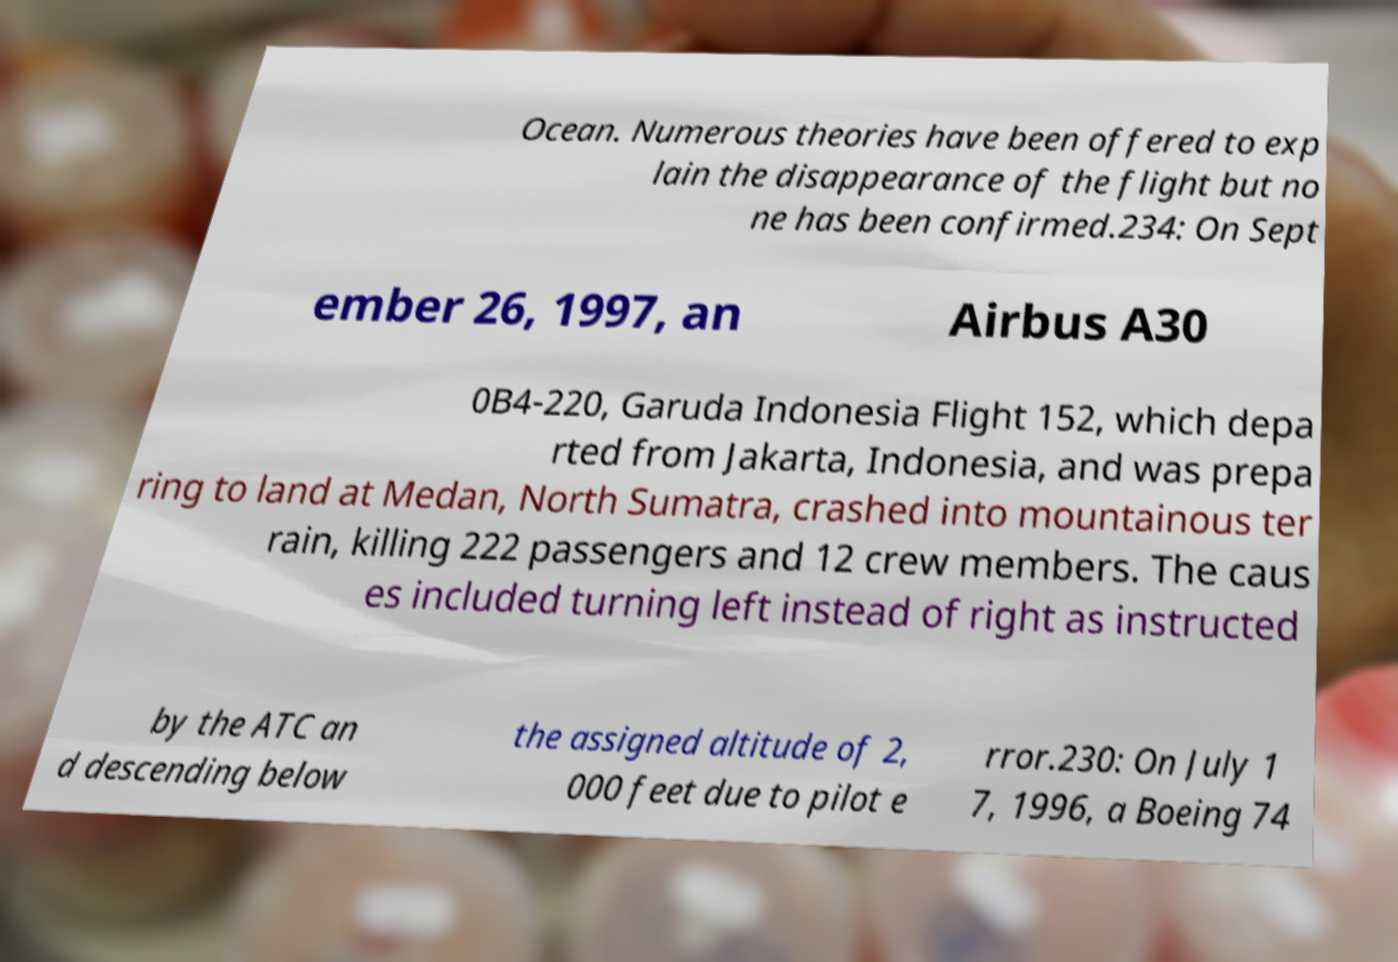Can you read and provide the text displayed in the image?This photo seems to have some interesting text. Can you extract and type it out for me? Ocean. Numerous theories have been offered to exp lain the disappearance of the flight but no ne has been confirmed.234: On Sept ember 26, 1997, an Airbus A30 0B4-220, Garuda Indonesia Flight 152, which depa rted from Jakarta, Indonesia, and was prepa ring to land at Medan, North Sumatra, crashed into mountainous ter rain, killing 222 passengers and 12 crew members. The caus es included turning left instead of right as instructed by the ATC an d descending below the assigned altitude of 2, 000 feet due to pilot e rror.230: On July 1 7, 1996, a Boeing 74 